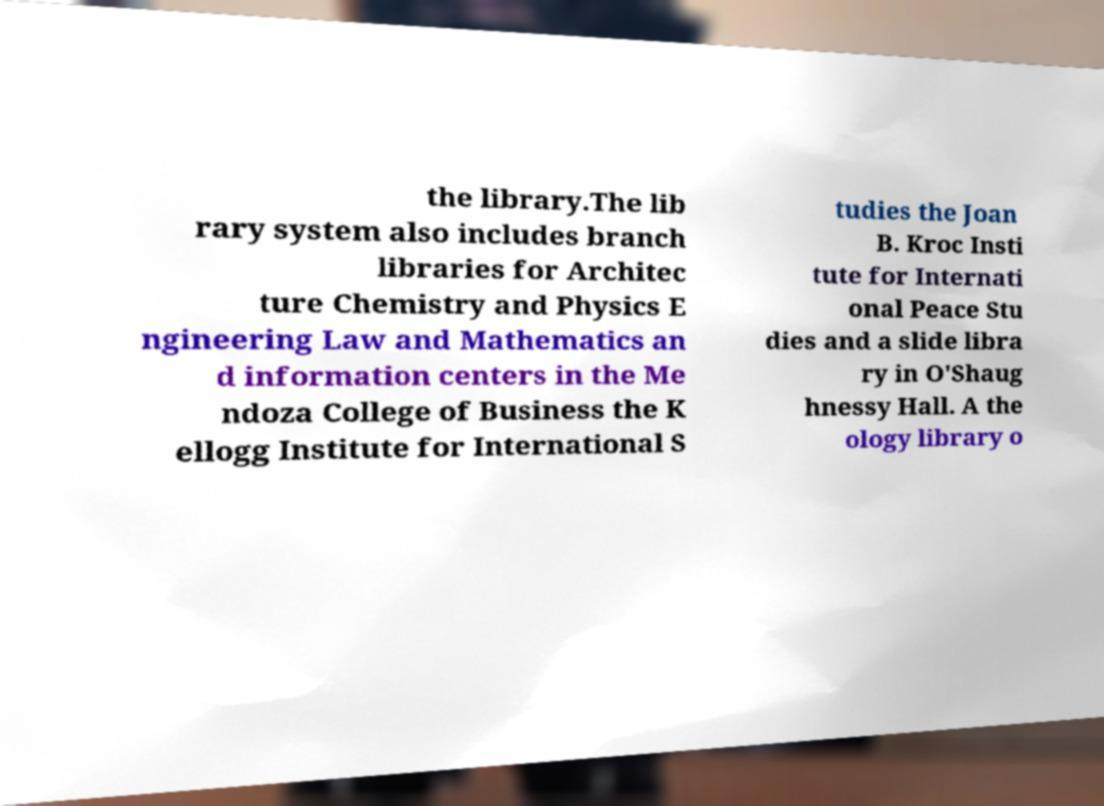What messages or text are displayed in this image? I need them in a readable, typed format. the library.The lib rary system also includes branch libraries for Architec ture Chemistry and Physics E ngineering Law and Mathematics an d information centers in the Me ndoza College of Business the K ellogg Institute for International S tudies the Joan B. Kroc Insti tute for Internati onal Peace Stu dies and a slide libra ry in O'Shaug hnessy Hall. A the ology library o 